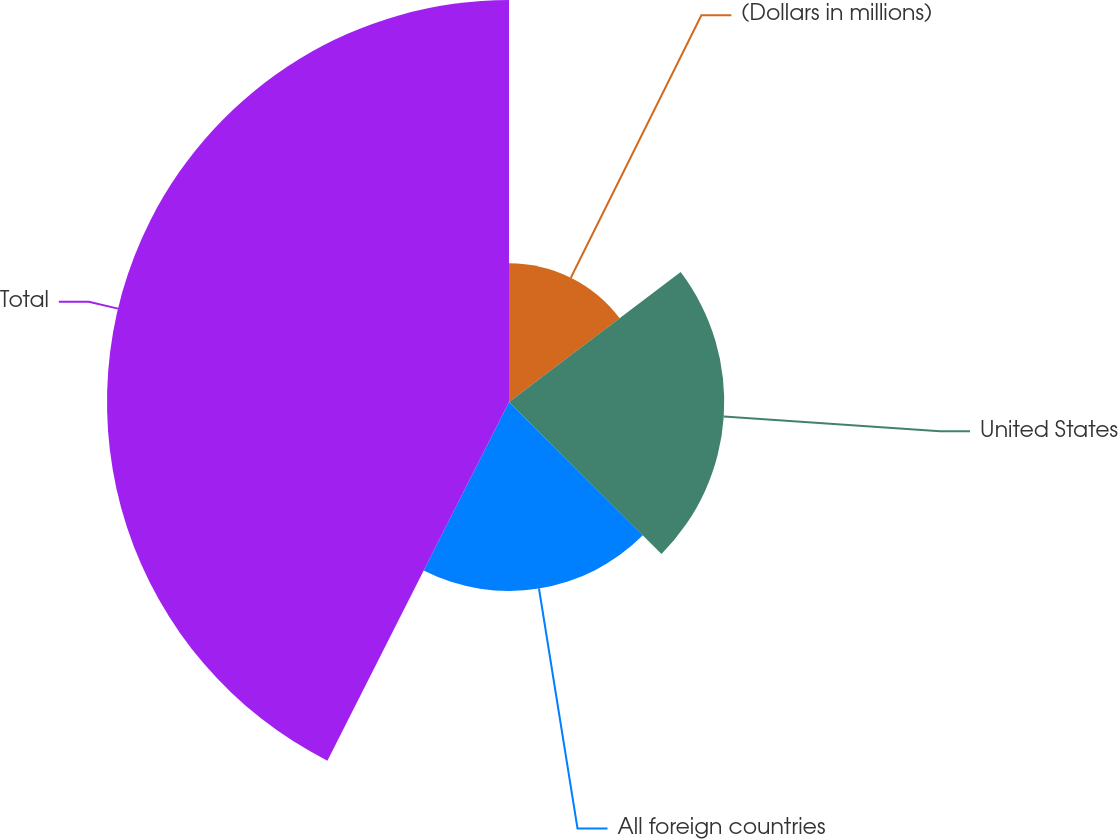<chart> <loc_0><loc_0><loc_500><loc_500><pie_chart><fcel>(Dollars in millions)<fcel>United States<fcel>All foreign countries<fcel>Total<nl><fcel>14.69%<fcel>22.78%<fcel>19.99%<fcel>42.54%<nl></chart> 